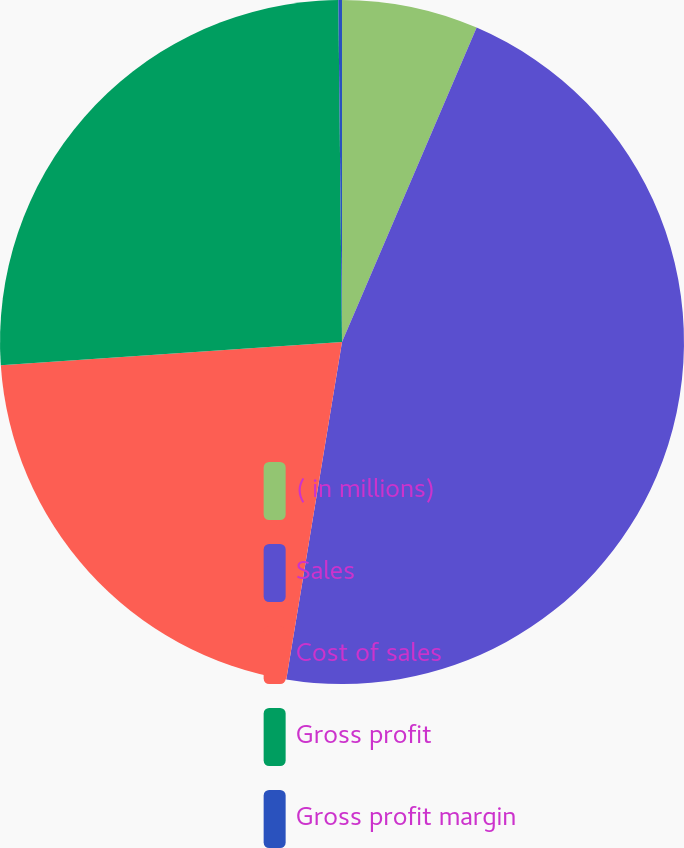Convert chart to OTSL. <chart><loc_0><loc_0><loc_500><loc_500><pie_chart><fcel>( in millions)<fcel>Sales<fcel>Cost of sales<fcel>Gross profit<fcel>Gross profit margin<nl><fcel>6.44%<fcel>46.16%<fcel>21.31%<fcel>25.91%<fcel>0.17%<nl></chart> 